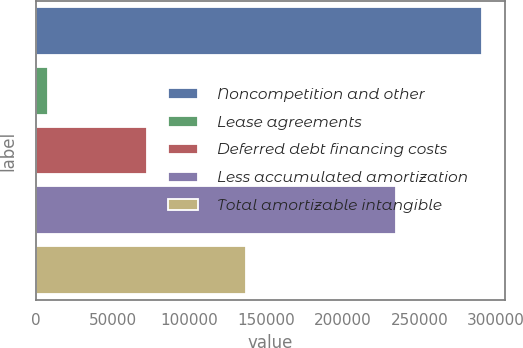Convert chart to OTSL. <chart><loc_0><loc_0><loc_500><loc_500><bar_chart><fcel>Noncompetition and other<fcel>Lease agreements<fcel>Deferred debt financing costs<fcel>Less accumulated amortization<fcel>Total amortizable intangible<nl><fcel>291022<fcel>8156<fcel>72656<fcel>235102<fcel>136732<nl></chart> 